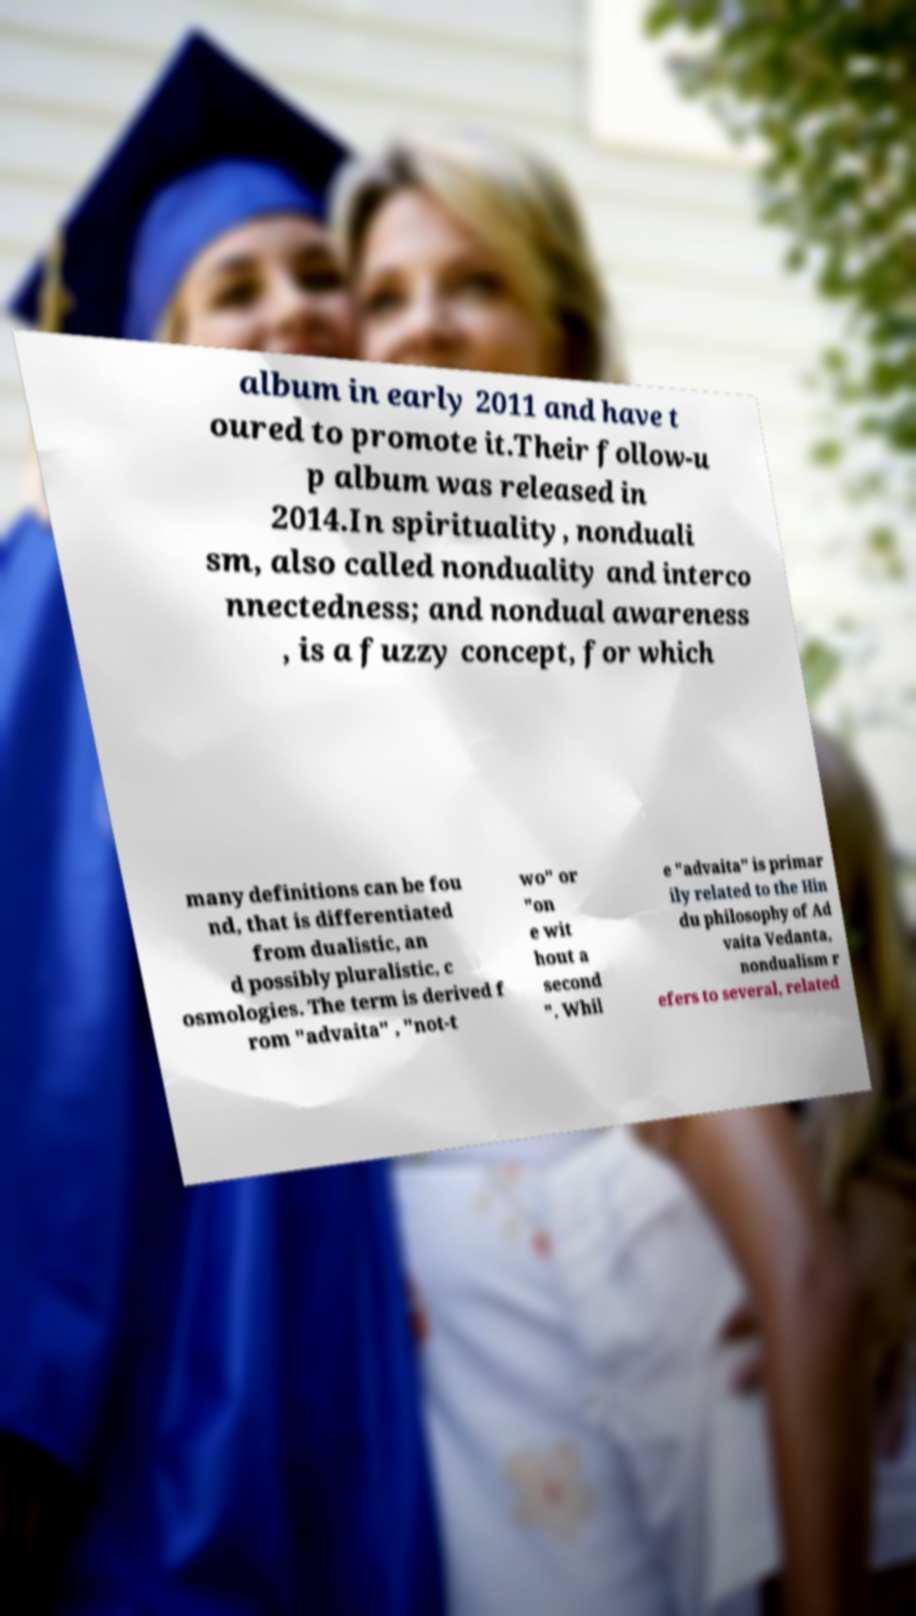Can you read and provide the text displayed in the image?This photo seems to have some interesting text. Can you extract and type it out for me? album in early 2011 and have t oured to promote it.Their follow-u p album was released in 2014.In spirituality, nonduali sm, also called nonduality and interco nnectedness; and nondual awareness , is a fuzzy concept, for which many definitions can be fou nd, that is differentiated from dualistic, an d possibly pluralistic, c osmologies. The term is derived f rom "advaita" , "not-t wo" or "on e wit hout a second ". Whil e "advaita" is primar ily related to the Hin du philosophy of Ad vaita Vedanta, nondualism r efers to several, related 